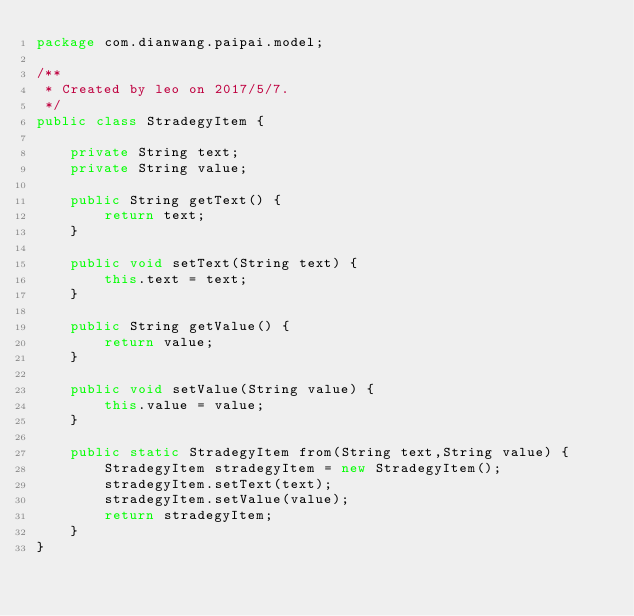Convert code to text. <code><loc_0><loc_0><loc_500><loc_500><_Java_>package com.dianwang.paipai.model;

/**
 * Created by leo on 2017/5/7.
 */
public class StradegyItem {

    private String text;
    private String value;

    public String getText() {
        return text;
    }

    public void setText(String text) {
        this.text = text;
    }

    public String getValue() {
        return value;
    }

    public void setValue(String value) {
        this.value = value;
    }

    public static StradegyItem from(String text,String value) {
        StradegyItem stradegyItem = new StradegyItem();
        stradegyItem.setText(text);
        stradegyItem.setValue(value);
        return stradegyItem;
    }
}
</code> 